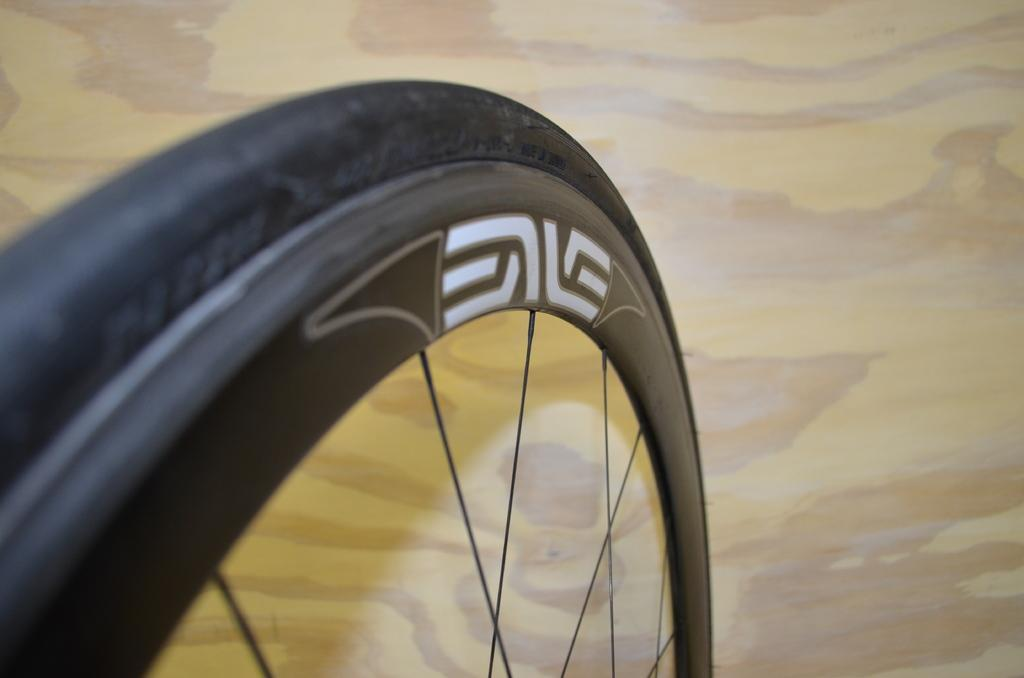What object is the main focus of the image? The main focus of the image is a wheel. Can you describe the color of the wheel? The wheel is black in color. What can be seen in the background of the image? The background of the image is brown. How many tomatoes can be seen in the image? There are no tomatoes present in the image. What letter does your dad write on the wheel in the image? There is no letter or person writing on the wheel in the image. 